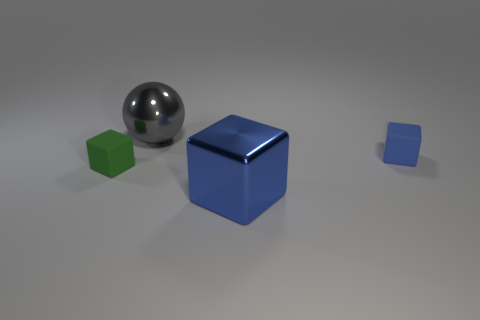There is a blue thing that is on the left side of the tiny blue matte object; what number of blue matte objects are right of it?
Your answer should be very brief. 1. Are there any tiny rubber objects of the same shape as the big blue object?
Your answer should be compact. Yes. Do the rubber object that is to the right of the blue shiny block and the metallic object that is in front of the big gray thing have the same size?
Make the answer very short. No. What shape is the rubber object that is left of the large metallic thing in front of the tiny blue rubber block?
Your response must be concise. Cube. How many green blocks are the same size as the ball?
Provide a short and direct response. 0. Are there any gray balls?
Offer a terse response. Yes. Are there any other things that have the same color as the big shiny sphere?
Offer a terse response. No. There is a large object that is made of the same material as the large block; what shape is it?
Your answer should be very brief. Sphere. There is a small object that is in front of the small matte thing on the right side of the small matte object to the left of the small blue rubber block; what color is it?
Your answer should be compact. Green. Are there an equal number of small matte objects on the right side of the tiny blue rubber thing and big spheres?
Your answer should be very brief. No. 